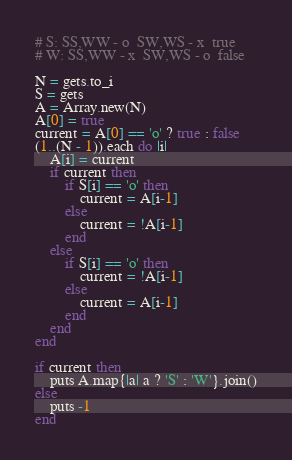<code> <loc_0><loc_0><loc_500><loc_500><_Ruby_># S: SS,WW - o  SW,WS - x  true
# W: SS,WW - x  SW,WS - o  false

N = gets.to_i
S = gets
A = Array.new(N)
A[0] = true
current = A[0] == 'o' ? true : false
(1..(N - 1)).each do |i|
    A[i] = current
    if current then
        if S[i] == 'o' then
            current = A[i-1]
        else
            current = !A[i-1]
        end
    else
        if S[i] == 'o' then
            current = !A[i-1]
        else
            current = A[i-1]
        end
    end
end

if current then
    puts A.map{|a| a ? 'S' : 'W'}.join()
else
    puts -1
end
</code> 